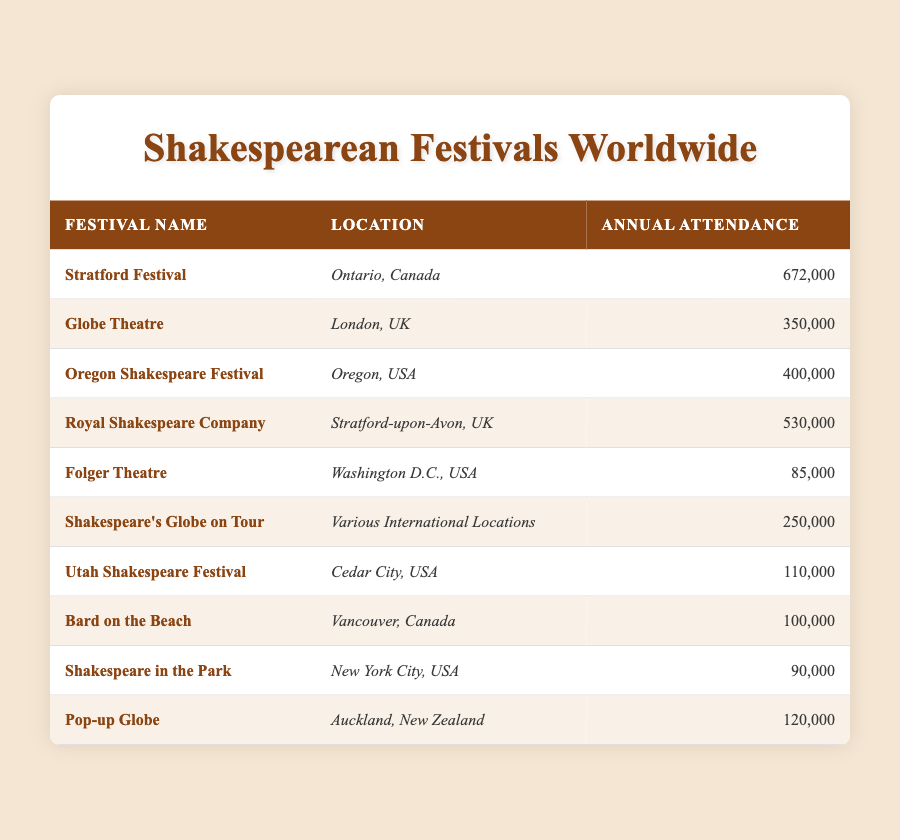What is the annual attendance at the Stratford Festival? The table lists the attendance figures for various Shakespearean festivals. The Stratford Festival in Ontario, Canada has an annual attendance of 672,000 according to the data in the table.
Answer: 672,000 Which festival has the lowest attendance? By looking at the annual attendance figures listed in the table, the lowest attendance is at the Folger Theatre in Washington D.C., USA, which has an attendance of 85,000.
Answer: 85,000 What is the total attendance of the Royal Shakespeare Company and the Oregon Shakespeare Festival? To find the total attendance, we sum the attendance figures of the Royal Shakespeare Company (530,000) and the Oregon Shakespeare Festival (400,000). Thus, 530,000 + 400,000 = 930,000.
Answer: 930,000 Is the attendance at Bard on the Beach more than 100,000? According to the table, Bard on the Beach, located in Vancouver, Canada, has an attendance of 100,000. Since 100,000 is not more than 100,000, the statement is false.
Answer: No Which festival has a higher attendance: Shakespeare in the Park or Pop-up Globe? Shakespeare in the Park has an attendance of 90,000 while Pop-up Globe has 120,000. Since 120,000 is greater than 90,000, Pop-up Globe has a higher attendance.
Answer: Pop-up Globe What is the average attendance of the festivals located in the USA? From the table, there are five festivals in the USA: Oregon Shakespeare Festival (400,000), Folger Theatre (85,000), Utah Shakespeare Festival (110,000), and Shakespeare in the Park (90,000). Adding their attendances gives us 400,000 + 85,000 + 110,000 + 90,000 = 685,000. To find the average, we divide that sum by 4 (the number of festivals): 685,000 / 4 = 171,250.
Answer: 171,250 How many festivals are there in Canada? The table lists two festivals in Canada: the Stratford Festival in Ontario and Bard on the Beach in Vancouver. Therefore, there are two festivals located in Canada.
Answer: 2 Which location has the highest combined attendance of Shakespearean festivals? The highest combined attendance will be from the locations mentioned in the data. The Royal Shakespeare Company (530,000), Globe Theatre (350,000), and Folger Theatre (85,000) are all in the UK. Their combined attendance is 530,000 + 350,000 + 85,000 = 965,000. The USA has a total of 685,000 (for the festivals listed). Therefore, UK has the highest combined attendance of 965,000.
Answer: UK (965,000) 